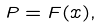Convert formula to latex. <formula><loc_0><loc_0><loc_500><loc_500>P = F ( x ) ,</formula> 